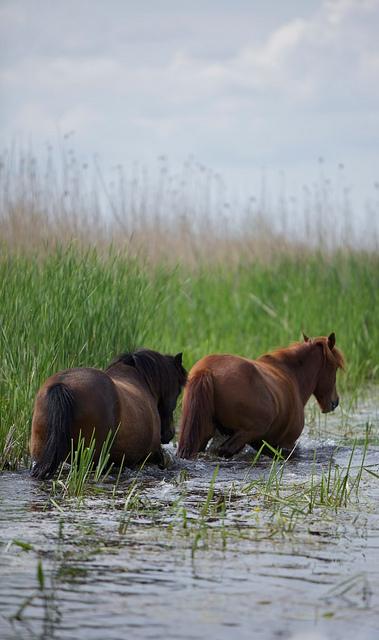Are these animals in the wild?
Write a very short answer. Yes. Can the horses swim?
Write a very short answer. Yes. How many horses are there?
Keep it brief. 2. What animal is this?
Give a very brief answer. Horse. What kinds of animal is this?
Give a very brief answer. Horse. Is it daytime?
Keep it brief. Yes. Is there a baby in the picture?
Be succinct. No. 